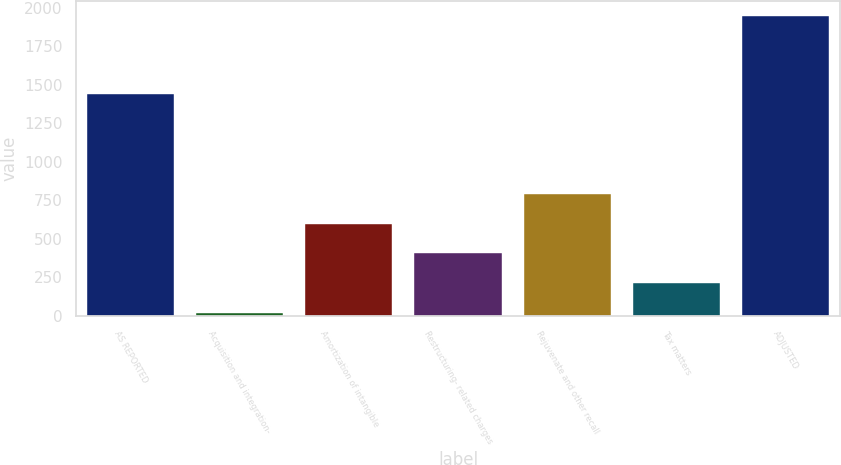<chart> <loc_0><loc_0><loc_500><loc_500><bar_chart><fcel>AS REPORTED<fcel>Acquisition and integration-<fcel>Amortization of intangible<fcel>Restructuring- related charges<fcel>Rejuvenate and other recall<fcel>Tax matters<fcel>ADJUSTED<nl><fcel>1439<fcel>20<fcel>598.7<fcel>405.8<fcel>791.6<fcel>212.9<fcel>1949<nl></chart> 